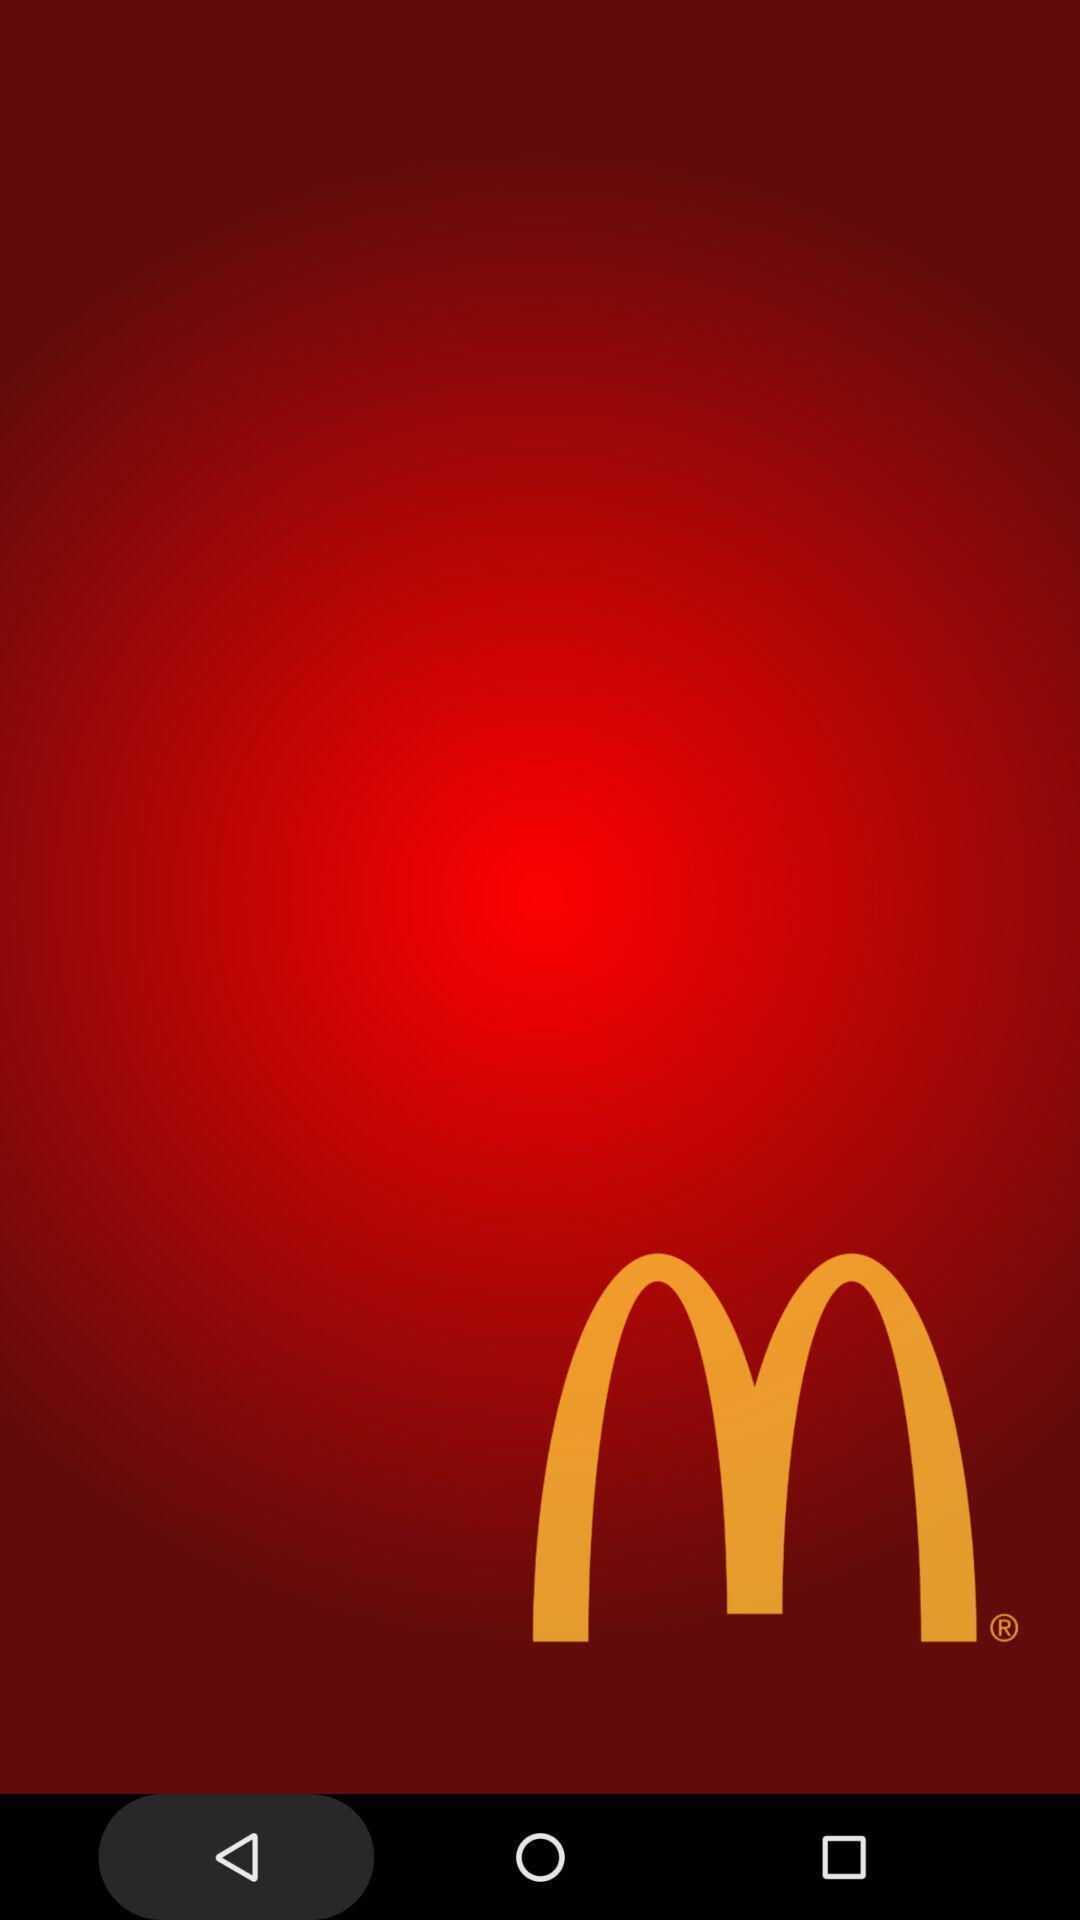What can you discern from this picture? Screen showing welcome page of a food app. 